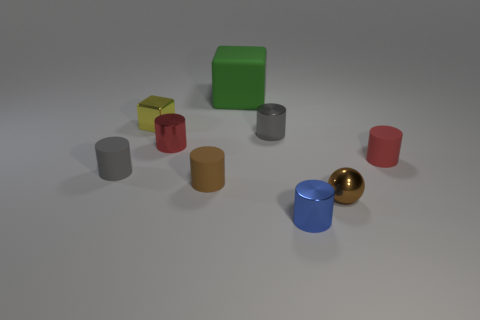Are there any red cylinders made of the same material as the big object?
Keep it short and to the point. Yes. The sphere has what color?
Provide a succinct answer. Brown. Is the shape of the small red object that is left of the red matte cylinder the same as  the tiny brown metallic thing?
Your answer should be compact. No. What is the shape of the tiny gray object on the left side of the metallic block that is on the left side of the metal cylinder to the left of the brown matte cylinder?
Keep it short and to the point. Cylinder. There is a tiny object right of the brown shiny sphere; what is it made of?
Make the answer very short. Rubber. There is a cube that is the same size as the brown shiny sphere; what color is it?
Make the answer very short. Yellow. How many other things are the same shape as the brown rubber thing?
Your answer should be very brief. 5. Is the size of the blue metal cylinder the same as the red rubber thing?
Your answer should be very brief. Yes. Is the number of metallic objects that are in front of the brown rubber cylinder greater than the number of large green cubes that are left of the small yellow block?
Provide a succinct answer. Yes. What number of other objects are the same size as the gray rubber thing?
Provide a succinct answer. 7. 